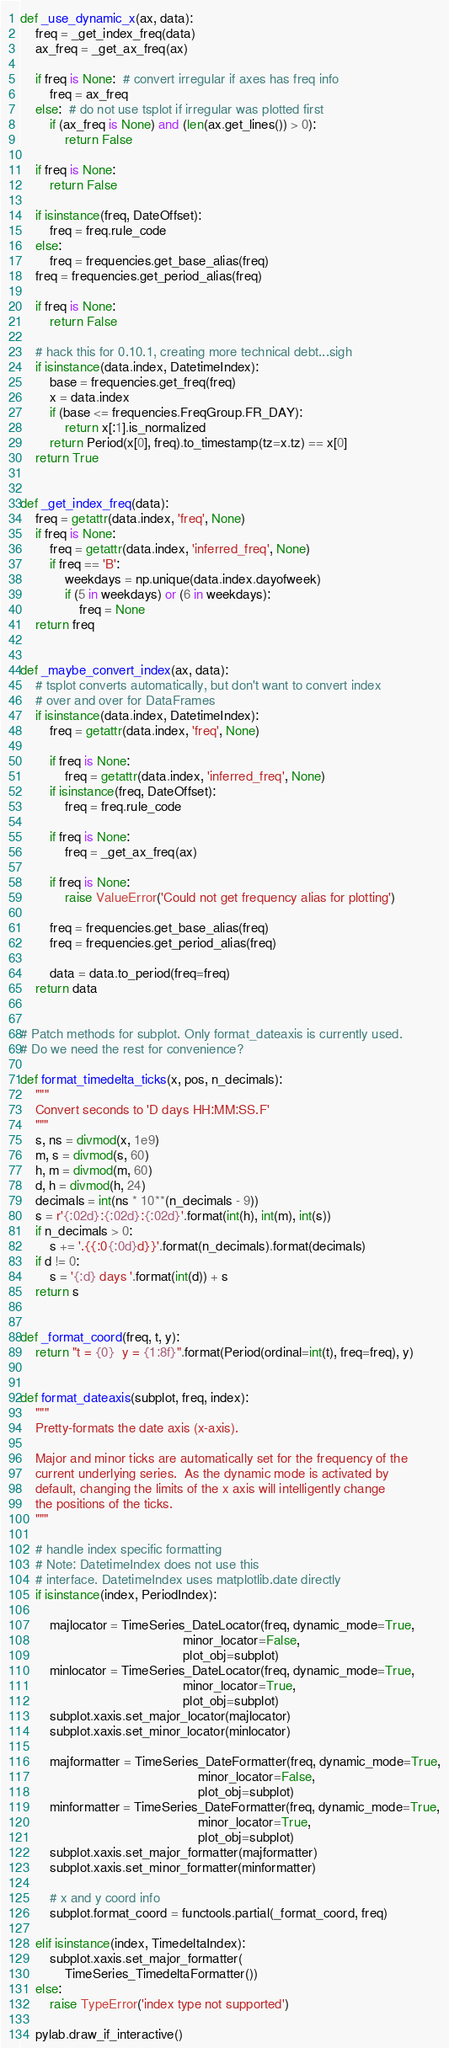<code> <loc_0><loc_0><loc_500><loc_500><_Python_>

def _use_dynamic_x(ax, data):
    freq = _get_index_freq(data)
    ax_freq = _get_ax_freq(ax)

    if freq is None:  # convert irregular if axes has freq info
        freq = ax_freq
    else:  # do not use tsplot if irregular was plotted first
        if (ax_freq is None) and (len(ax.get_lines()) > 0):
            return False

    if freq is None:
        return False

    if isinstance(freq, DateOffset):
        freq = freq.rule_code
    else:
        freq = frequencies.get_base_alias(freq)
    freq = frequencies.get_period_alias(freq)

    if freq is None:
        return False

    # hack this for 0.10.1, creating more technical debt...sigh
    if isinstance(data.index, DatetimeIndex):
        base = frequencies.get_freq(freq)
        x = data.index
        if (base <= frequencies.FreqGroup.FR_DAY):
            return x[:1].is_normalized
        return Period(x[0], freq).to_timestamp(tz=x.tz) == x[0]
    return True


def _get_index_freq(data):
    freq = getattr(data.index, 'freq', None)
    if freq is None:
        freq = getattr(data.index, 'inferred_freq', None)
        if freq == 'B':
            weekdays = np.unique(data.index.dayofweek)
            if (5 in weekdays) or (6 in weekdays):
                freq = None
    return freq


def _maybe_convert_index(ax, data):
    # tsplot converts automatically, but don't want to convert index
    # over and over for DataFrames
    if isinstance(data.index, DatetimeIndex):
        freq = getattr(data.index, 'freq', None)

        if freq is None:
            freq = getattr(data.index, 'inferred_freq', None)
        if isinstance(freq, DateOffset):
            freq = freq.rule_code

        if freq is None:
            freq = _get_ax_freq(ax)

        if freq is None:
            raise ValueError('Could not get frequency alias for plotting')

        freq = frequencies.get_base_alias(freq)
        freq = frequencies.get_period_alias(freq)

        data = data.to_period(freq=freq)
    return data


# Patch methods for subplot. Only format_dateaxis is currently used.
# Do we need the rest for convenience?

def format_timedelta_ticks(x, pos, n_decimals):
    """
    Convert seconds to 'D days HH:MM:SS.F'
    """
    s, ns = divmod(x, 1e9)
    m, s = divmod(s, 60)
    h, m = divmod(m, 60)
    d, h = divmod(h, 24)
    decimals = int(ns * 10**(n_decimals - 9))
    s = r'{:02d}:{:02d}:{:02d}'.format(int(h), int(m), int(s))
    if n_decimals > 0:
        s += '.{{:0{:0d}d}}'.format(n_decimals).format(decimals)
    if d != 0:
        s = '{:d} days '.format(int(d)) + s
    return s


def _format_coord(freq, t, y):
    return "t = {0}  y = {1:8f}".format(Period(ordinal=int(t), freq=freq), y)


def format_dateaxis(subplot, freq, index):
    """
    Pretty-formats the date axis (x-axis).

    Major and minor ticks are automatically set for the frequency of the
    current underlying series.  As the dynamic mode is activated by
    default, changing the limits of the x axis will intelligently change
    the positions of the ticks.
    """

    # handle index specific formatting
    # Note: DatetimeIndex does not use this
    # interface. DatetimeIndex uses matplotlib.date directly
    if isinstance(index, PeriodIndex):

        majlocator = TimeSeries_DateLocator(freq, dynamic_mode=True,
                                            minor_locator=False,
                                            plot_obj=subplot)
        minlocator = TimeSeries_DateLocator(freq, dynamic_mode=True,
                                            minor_locator=True,
                                            plot_obj=subplot)
        subplot.xaxis.set_major_locator(majlocator)
        subplot.xaxis.set_minor_locator(minlocator)

        majformatter = TimeSeries_DateFormatter(freq, dynamic_mode=True,
                                                minor_locator=False,
                                                plot_obj=subplot)
        minformatter = TimeSeries_DateFormatter(freq, dynamic_mode=True,
                                                minor_locator=True,
                                                plot_obj=subplot)
        subplot.xaxis.set_major_formatter(majformatter)
        subplot.xaxis.set_minor_formatter(minformatter)

        # x and y coord info
        subplot.format_coord = functools.partial(_format_coord, freq)

    elif isinstance(index, TimedeltaIndex):
        subplot.xaxis.set_major_formatter(
            TimeSeries_TimedeltaFormatter())
    else:
        raise TypeError('index type not supported')

    pylab.draw_if_interactive()
</code> 